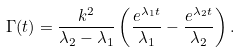<formula> <loc_0><loc_0><loc_500><loc_500>\Gamma ( t ) = \frac { k ^ { 2 } } { \lambda _ { 2 } - \lambda _ { 1 } } \left ( \frac { e ^ { \lambda _ { 1 } t } } { \lambda _ { 1 } } - \frac { e ^ { \lambda _ { 2 } t } } { \lambda _ { 2 } } \right ) .</formula> 